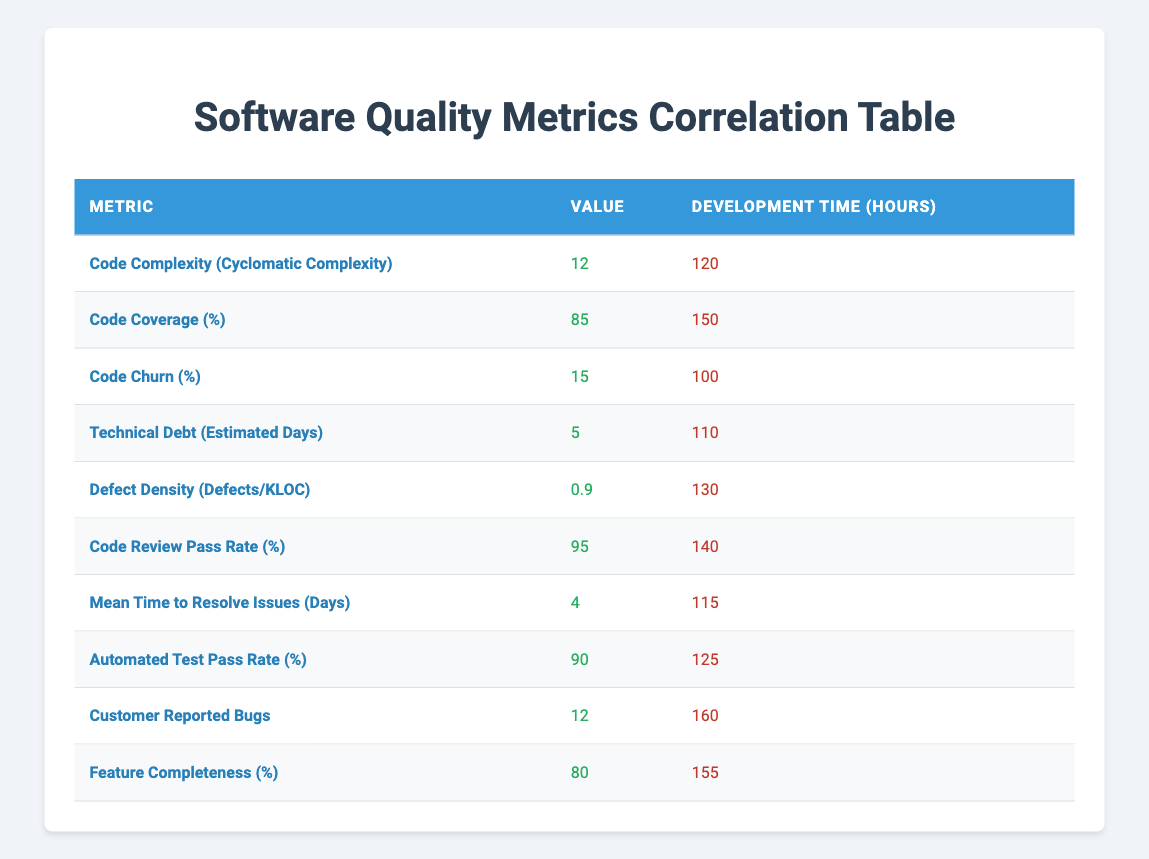What is the development time for the Code Coverage metric? The Code Coverage metric shows a development time of 150 hours directly stated in the table.
Answer: 150 hours How many metrics have a development time greater than 130 hours? By examining the table, the metrics with a development time greater than 130 hours are Code Coverage (150), Customer Reported Bugs (160), and Feature Completeness (155). This gives a total of 3 metrics.
Answer: 3 What is the average development time for the metrics listed in the table? To find the average development time, sum the individual development times (120 + 150 + 100 + 110 + 130 + 140 + 115 + 125 + 160 + 155 = 1380) and then divide by the number of metrics (10). The average is 1380 / 10 = 138 hours.
Answer: 138 hours Is the Customer Reported Bugs metric associated with the longest development time? The table shows that the Customer Reported Bugs metric has a development time of 160 hours, which is indeed the highest compared to all other metrics listed.
Answer: Yes What is the difference in development time between the Code Review Pass Rate and the Defect Density metrics? The development time for Code Review Pass Rate is 140 hours and for Defect Density, it is 130 hours. The difference is 140 - 130 = 10 hours.
Answer: 10 hours What percentage of the metrics listed have a value of greater than 80 for their respective quality metrics? There are 10 metrics in total, and those with values greater than 80 are Code Coverage (85), Code Review Pass Rate (95), Automated Test Pass Rate (90), and Feature Completeness (80). Excluding Feature Completeness, there are 3 metrics above 80 out of 10 total. Therefore, (3/10) * 100 = 30%.
Answer: 30% Which metric has the highest value and what is the associated development time? The metric with the highest value is Code Review Pass Rate at 95%, and it has an associated development time of 140 hours as shown in the table.
Answer: Code Review Pass Rate, 140 hours What is the sum of Code Churn and Technical Debt values? The value for Code Churn is 15, and for Technical Debt, it is 5. Their sum is 15 + 5 = 20.
Answer: 20 